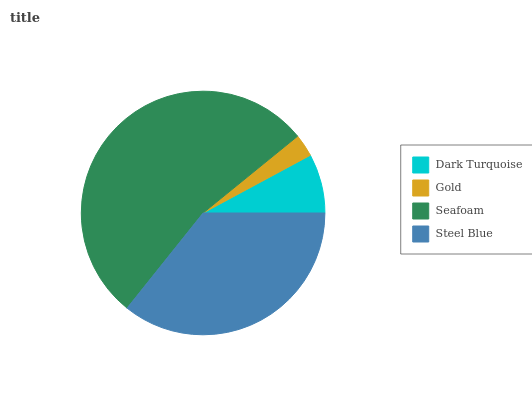Is Gold the minimum?
Answer yes or no. Yes. Is Seafoam the maximum?
Answer yes or no. Yes. Is Seafoam the minimum?
Answer yes or no. No. Is Gold the maximum?
Answer yes or no. No. Is Seafoam greater than Gold?
Answer yes or no. Yes. Is Gold less than Seafoam?
Answer yes or no. Yes. Is Gold greater than Seafoam?
Answer yes or no. No. Is Seafoam less than Gold?
Answer yes or no. No. Is Steel Blue the high median?
Answer yes or no. Yes. Is Dark Turquoise the low median?
Answer yes or no. Yes. Is Dark Turquoise the high median?
Answer yes or no. No. Is Steel Blue the low median?
Answer yes or no. No. 